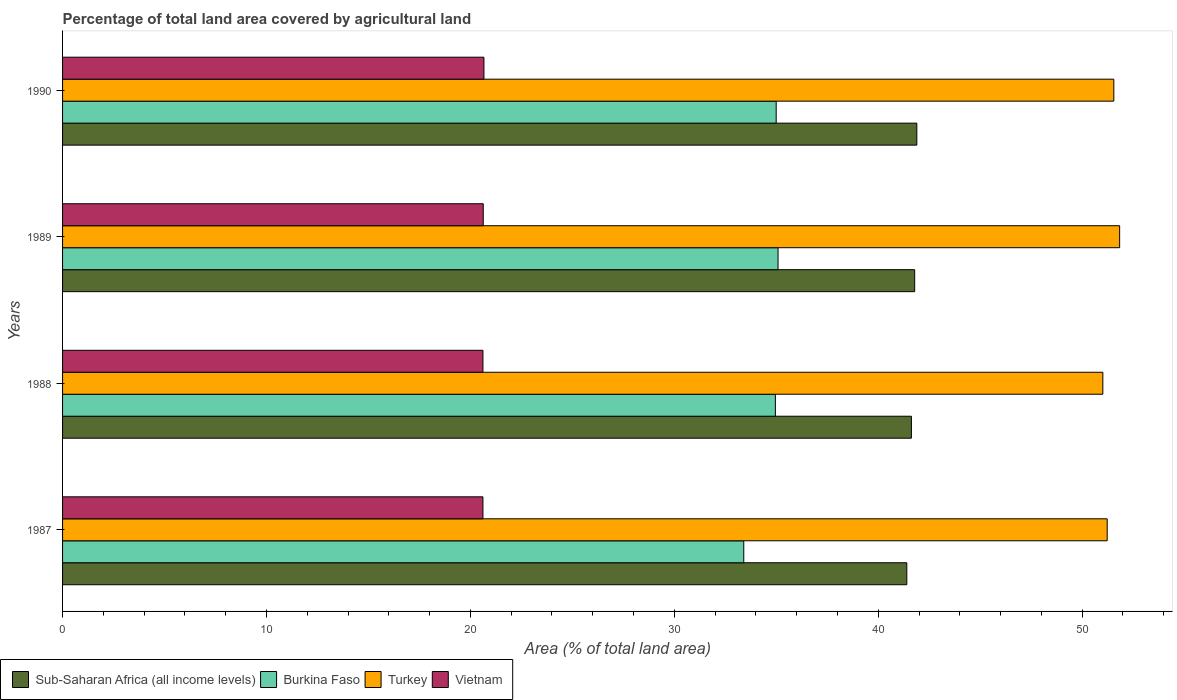Are the number of bars on each tick of the Y-axis equal?
Offer a terse response. Yes. How many bars are there on the 2nd tick from the top?
Offer a terse response. 4. What is the label of the 4th group of bars from the top?
Your response must be concise. 1987. In how many cases, is the number of bars for a given year not equal to the number of legend labels?
Offer a terse response. 0. What is the percentage of agricultural land in Sub-Saharan Africa (all income levels) in 1987?
Provide a short and direct response. 41.4. Across all years, what is the maximum percentage of agricultural land in Sub-Saharan Africa (all income levels)?
Provide a short and direct response. 41.89. Across all years, what is the minimum percentage of agricultural land in Vietnam?
Offer a terse response. 20.62. In which year was the percentage of agricultural land in Vietnam minimum?
Provide a short and direct response. 1987. What is the total percentage of agricultural land in Turkey in the graph?
Offer a terse response. 205.64. What is the difference between the percentage of agricultural land in Sub-Saharan Africa (all income levels) in 1987 and that in 1990?
Ensure brevity in your answer.  -0.49. What is the difference between the percentage of agricultural land in Sub-Saharan Africa (all income levels) in 1987 and the percentage of agricultural land in Burkina Faso in 1988?
Your answer should be very brief. 6.45. What is the average percentage of agricultural land in Turkey per year?
Your answer should be very brief. 51.41. In the year 1987, what is the difference between the percentage of agricultural land in Vietnam and percentage of agricultural land in Turkey?
Provide a short and direct response. -30.61. In how many years, is the percentage of agricultural land in Sub-Saharan Africa (all income levels) greater than 48 %?
Offer a terse response. 0. What is the ratio of the percentage of agricultural land in Burkina Faso in 1987 to that in 1990?
Give a very brief answer. 0.95. Is the percentage of agricultural land in Sub-Saharan Africa (all income levels) in 1987 less than that in 1988?
Provide a succinct answer. Yes. What is the difference between the highest and the second highest percentage of agricultural land in Sub-Saharan Africa (all income levels)?
Offer a terse response. 0.11. What is the difference between the highest and the lowest percentage of agricultural land in Vietnam?
Keep it short and to the point. 0.05. Is it the case that in every year, the sum of the percentage of agricultural land in Vietnam and percentage of agricultural land in Burkina Faso is greater than the sum of percentage of agricultural land in Turkey and percentage of agricultural land in Sub-Saharan Africa (all income levels)?
Ensure brevity in your answer.  No. What does the 2nd bar from the top in 1989 represents?
Give a very brief answer. Turkey. What does the 4th bar from the bottom in 1987 represents?
Offer a very short reply. Vietnam. Is it the case that in every year, the sum of the percentage of agricultural land in Burkina Faso and percentage of agricultural land in Turkey is greater than the percentage of agricultural land in Sub-Saharan Africa (all income levels)?
Offer a terse response. Yes. How many bars are there?
Offer a very short reply. 16. What is the difference between two consecutive major ticks on the X-axis?
Your answer should be compact. 10. Does the graph contain any zero values?
Provide a short and direct response. No. Does the graph contain grids?
Your answer should be compact. No. Where does the legend appear in the graph?
Offer a very short reply. Bottom left. How are the legend labels stacked?
Offer a very short reply. Horizontal. What is the title of the graph?
Your response must be concise. Percentage of total land area covered by agricultural land. What is the label or title of the X-axis?
Offer a terse response. Area (% of total land area). What is the label or title of the Y-axis?
Keep it short and to the point. Years. What is the Area (% of total land area) in Sub-Saharan Africa (all income levels) in 1987?
Keep it short and to the point. 41.4. What is the Area (% of total land area) in Burkina Faso in 1987?
Offer a terse response. 33.41. What is the Area (% of total land area) in Turkey in 1987?
Ensure brevity in your answer.  51.23. What is the Area (% of total land area) of Vietnam in 1987?
Provide a short and direct response. 20.62. What is the Area (% of total land area) of Sub-Saharan Africa (all income levels) in 1988?
Give a very brief answer. 41.63. What is the Area (% of total land area) of Burkina Faso in 1988?
Provide a short and direct response. 34.96. What is the Area (% of total land area) in Turkey in 1988?
Your response must be concise. 51.02. What is the Area (% of total land area) of Vietnam in 1988?
Give a very brief answer. 20.62. What is the Area (% of total land area) in Sub-Saharan Africa (all income levels) in 1989?
Keep it short and to the point. 41.79. What is the Area (% of total land area) in Burkina Faso in 1989?
Make the answer very short. 35.09. What is the Area (% of total land area) in Turkey in 1989?
Your answer should be very brief. 51.84. What is the Area (% of total land area) in Vietnam in 1989?
Provide a short and direct response. 20.63. What is the Area (% of total land area) of Sub-Saharan Africa (all income levels) in 1990?
Your answer should be compact. 41.89. What is the Area (% of total land area) of Burkina Faso in 1990?
Give a very brief answer. 35. What is the Area (% of total land area) of Turkey in 1990?
Your answer should be compact. 51.55. What is the Area (% of total land area) of Vietnam in 1990?
Offer a terse response. 20.66. Across all years, what is the maximum Area (% of total land area) in Sub-Saharan Africa (all income levels)?
Offer a very short reply. 41.89. Across all years, what is the maximum Area (% of total land area) in Burkina Faso?
Offer a terse response. 35.09. Across all years, what is the maximum Area (% of total land area) in Turkey?
Give a very brief answer. 51.84. Across all years, what is the maximum Area (% of total land area) of Vietnam?
Offer a very short reply. 20.66. Across all years, what is the minimum Area (% of total land area) of Sub-Saharan Africa (all income levels)?
Keep it short and to the point. 41.4. Across all years, what is the minimum Area (% of total land area) in Burkina Faso?
Your response must be concise. 33.41. Across all years, what is the minimum Area (% of total land area) of Turkey?
Your response must be concise. 51.02. Across all years, what is the minimum Area (% of total land area) of Vietnam?
Make the answer very short. 20.62. What is the total Area (% of total land area) of Sub-Saharan Africa (all income levels) in the graph?
Give a very brief answer. 166.71. What is the total Area (% of total land area) of Burkina Faso in the graph?
Keep it short and to the point. 138.45. What is the total Area (% of total land area) of Turkey in the graph?
Offer a terse response. 205.64. What is the total Area (% of total land area) of Vietnam in the graph?
Ensure brevity in your answer.  82.52. What is the difference between the Area (% of total land area) in Sub-Saharan Africa (all income levels) in 1987 and that in 1988?
Offer a very short reply. -0.22. What is the difference between the Area (% of total land area) of Burkina Faso in 1987 and that in 1988?
Your response must be concise. -1.55. What is the difference between the Area (% of total land area) of Turkey in 1987 and that in 1988?
Keep it short and to the point. 0.21. What is the difference between the Area (% of total land area) in Vietnam in 1987 and that in 1988?
Ensure brevity in your answer.  0. What is the difference between the Area (% of total land area) in Sub-Saharan Africa (all income levels) in 1987 and that in 1989?
Ensure brevity in your answer.  -0.38. What is the difference between the Area (% of total land area) of Burkina Faso in 1987 and that in 1989?
Keep it short and to the point. -1.68. What is the difference between the Area (% of total land area) of Turkey in 1987 and that in 1989?
Your answer should be very brief. -0.61. What is the difference between the Area (% of total land area) of Vietnam in 1987 and that in 1989?
Your answer should be very brief. -0.02. What is the difference between the Area (% of total land area) in Sub-Saharan Africa (all income levels) in 1987 and that in 1990?
Provide a short and direct response. -0.49. What is the difference between the Area (% of total land area) of Burkina Faso in 1987 and that in 1990?
Your response must be concise. -1.59. What is the difference between the Area (% of total land area) of Turkey in 1987 and that in 1990?
Offer a very short reply. -0.32. What is the difference between the Area (% of total land area) of Vietnam in 1987 and that in 1990?
Provide a short and direct response. -0.05. What is the difference between the Area (% of total land area) of Sub-Saharan Africa (all income levels) in 1988 and that in 1989?
Provide a succinct answer. -0.16. What is the difference between the Area (% of total land area) in Burkina Faso in 1988 and that in 1989?
Keep it short and to the point. -0.13. What is the difference between the Area (% of total land area) of Turkey in 1988 and that in 1989?
Ensure brevity in your answer.  -0.82. What is the difference between the Area (% of total land area) of Vietnam in 1988 and that in 1989?
Offer a very short reply. -0.02. What is the difference between the Area (% of total land area) of Sub-Saharan Africa (all income levels) in 1988 and that in 1990?
Offer a very short reply. -0.27. What is the difference between the Area (% of total land area) of Burkina Faso in 1988 and that in 1990?
Provide a short and direct response. -0.04. What is the difference between the Area (% of total land area) of Turkey in 1988 and that in 1990?
Your answer should be compact. -0.54. What is the difference between the Area (% of total land area) in Vietnam in 1988 and that in 1990?
Your answer should be compact. -0.05. What is the difference between the Area (% of total land area) of Sub-Saharan Africa (all income levels) in 1989 and that in 1990?
Provide a short and direct response. -0.11. What is the difference between the Area (% of total land area) in Burkina Faso in 1989 and that in 1990?
Give a very brief answer. 0.09. What is the difference between the Area (% of total land area) of Turkey in 1989 and that in 1990?
Provide a short and direct response. 0.29. What is the difference between the Area (% of total land area) of Vietnam in 1989 and that in 1990?
Ensure brevity in your answer.  -0.03. What is the difference between the Area (% of total land area) of Sub-Saharan Africa (all income levels) in 1987 and the Area (% of total land area) of Burkina Faso in 1988?
Your answer should be compact. 6.45. What is the difference between the Area (% of total land area) of Sub-Saharan Africa (all income levels) in 1987 and the Area (% of total land area) of Turkey in 1988?
Offer a terse response. -9.61. What is the difference between the Area (% of total land area) of Sub-Saharan Africa (all income levels) in 1987 and the Area (% of total land area) of Vietnam in 1988?
Offer a very short reply. 20.79. What is the difference between the Area (% of total land area) in Burkina Faso in 1987 and the Area (% of total land area) in Turkey in 1988?
Your answer should be compact. -17.61. What is the difference between the Area (% of total land area) of Burkina Faso in 1987 and the Area (% of total land area) of Vietnam in 1988?
Make the answer very short. 12.79. What is the difference between the Area (% of total land area) of Turkey in 1987 and the Area (% of total land area) of Vietnam in 1988?
Your answer should be compact. 30.61. What is the difference between the Area (% of total land area) of Sub-Saharan Africa (all income levels) in 1987 and the Area (% of total land area) of Burkina Faso in 1989?
Offer a terse response. 6.31. What is the difference between the Area (% of total land area) of Sub-Saharan Africa (all income levels) in 1987 and the Area (% of total land area) of Turkey in 1989?
Offer a very short reply. -10.44. What is the difference between the Area (% of total land area) of Sub-Saharan Africa (all income levels) in 1987 and the Area (% of total land area) of Vietnam in 1989?
Your answer should be compact. 20.77. What is the difference between the Area (% of total land area) in Burkina Faso in 1987 and the Area (% of total land area) in Turkey in 1989?
Your answer should be compact. -18.43. What is the difference between the Area (% of total land area) of Burkina Faso in 1987 and the Area (% of total land area) of Vietnam in 1989?
Provide a short and direct response. 12.78. What is the difference between the Area (% of total land area) of Turkey in 1987 and the Area (% of total land area) of Vietnam in 1989?
Your answer should be compact. 30.6. What is the difference between the Area (% of total land area) in Sub-Saharan Africa (all income levels) in 1987 and the Area (% of total land area) in Burkina Faso in 1990?
Offer a terse response. 6.41. What is the difference between the Area (% of total land area) of Sub-Saharan Africa (all income levels) in 1987 and the Area (% of total land area) of Turkey in 1990?
Ensure brevity in your answer.  -10.15. What is the difference between the Area (% of total land area) in Sub-Saharan Africa (all income levels) in 1987 and the Area (% of total land area) in Vietnam in 1990?
Your answer should be compact. 20.74. What is the difference between the Area (% of total land area) in Burkina Faso in 1987 and the Area (% of total land area) in Turkey in 1990?
Your response must be concise. -18.15. What is the difference between the Area (% of total land area) in Burkina Faso in 1987 and the Area (% of total land area) in Vietnam in 1990?
Your response must be concise. 12.74. What is the difference between the Area (% of total land area) in Turkey in 1987 and the Area (% of total land area) in Vietnam in 1990?
Offer a terse response. 30.56. What is the difference between the Area (% of total land area) of Sub-Saharan Africa (all income levels) in 1988 and the Area (% of total land area) of Burkina Faso in 1989?
Your response must be concise. 6.54. What is the difference between the Area (% of total land area) of Sub-Saharan Africa (all income levels) in 1988 and the Area (% of total land area) of Turkey in 1989?
Offer a terse response. -10.21. What is the difference between the Area (% of total land area) of Sub-Saharan Africa (all income levels) in 1988 and the Area (% of total land area) of Vietnam in 1989?
Offer a very short reply. 21. What is the difference between the Area (% of total land area) in Burkina Faso in 1988 and the Area (% of total land area) in Turkey in 1989?
Offer a very short reply. -16.88. What is the difference between the Area (% of total land area) in Burkina Faso in 1988 and the Area (% of total land area) in Vietnam in 1989?
Provide a short and direct response. 14.33. What is the difference between the Area (% of total land area) of Turkey in 1988 and the Area (% of total land area) of Vietnam in 1989?
Ensure brevity in your answer.  30.39. What is the difference between the Area (% of total land area) in Sub-Saharan Africa (all income levels) in 1988 and the Area (% of total land area) in Burkina Faso in 1990?
Your answer should be very brief. 6.63. What is the difference between the Area (% of total land area) in Sub-Saharan Africa (all income levels) in 1988 and the Area (% of total land area) in Turkey in 1990?
Ensure brevity in your answer.  -9.93. What is the difference between the Area (% of total land area) of Sub-Saharan Africa (all income levels) in 1988 and the Area (% of total land area) of Vietnam in 1990?
Offer a very short reply. 20.96. What is the difference between the Area (% of total land area) of Burkina Faso in 1988 and the Area (% of total land area) of Turkey in 1990?
Give a very brief answer. -16.6. What is the difference between the Area (% of total land area) in Burkina Faso in 1988 and the Area (% of total land area) in Vietnam in 1990?
Make the answer very short. 14.29. What is the difference between the Area (% of total land area) in Turkey in 1988 and the Area (% of total land area) in Vietnam in 1990?
Provide a short and direct response. 30.35. What is the difference between the Area (% of total land area) in Sub-Saharan Africa (all income levels) in 1989 and the Area (% of total land area) in Burkina Faso in 1990?
Provide a succinct answer. 6.79. What is the difference between the Area (% of total land area) in Sub-Saharan Africa (all income levels) in 1989 and the Area (% of total land area) in Turkey in 1990?
Provide a short and direct response. -9.77. What is the difference between the Area (% of total land area) of Sub-Saharan Africa (all income levels) in 1989 and the Area (% of total land area) of Vietnam in 1990?
Make the answer very short. 21.12. What is the difference between the Area (% of total land area) of Burkina Faso in 1989 and the Area (% of total land area) of Turkey in 1990?
Keep it short and to the point. -16.47. What is the difference between the Area (% of total land area) in Burkina Faso in 1989 and the Area (% of total land area) in Vietnam in 1990?
Give a very brief answer. 14.42. What is the difference between the Area (% of total land area) in Turkey in 1989 and the Area (% of total land area) in Vietnam in 1990?
Provide a succinct answer. 31.18. What is the average Area (% of total land area) in Sub-Saharan Africa (all income levels) per year?
Your answer should be very brief. 41.68. What is the average Area (% of total land area) of Burkina Faso per year?
Make the answer very short. 34.61. What is the average Area (% of total land area) in Turkey per year?
Provide a short and direct response. 51.41. What is the average Area (% of total land area) in Vietnam per year?
Offer a very short reply. 20.63. In the year 1987, what is the difference between the Area (% of total land area) of Sub-Saharan Africa (all income levels) and Area (% of total land area) of Burkina Faso?
Offer a terse response. 8. In the year 1987, what is the difference between the Area (% of total land area) of Sub-Saharan Africa (all income levels) and Area (% of total land area) of Turkey?
Your answer should be very brief. -9.83. In the year 1987, what is the difference between the Area (% of total land area) of Sub-Saharan Africa (all income levels) and Area (% of total land area) of Vietnam?
Give a very brief answer. 20.79. In the year 1987, what is the difference between the Area (% of total land area) in Burkina Faso and Area (% of total land area) in Turkey?
Your response must be concise. -17.82. In the year 1987, what is the difference between the Area (% of total land area) in Burkina Faso and Area (% of total land area) in Vietnam?
Make the answer very short. 12.79. In the year 1987, what is the difference between the Area (% of total land area) of Turkey and Area (% of total land area) of Vietnam?
Ensure brevity in your answer.  30.61. In the year 1988, what is the difference between the Area (% of total land area) in Sub-Saharan Africa (all income levels) and Area (% of total land area) in Burkina Faso?
Offer a very short reply. 6.67. In the year 1988, what is the difference between the Area (% of total land area) of Sub-Saharan Africa (all income levels) and Area (% of total land area) of Turkey?
Your answer should be very brief. -9.39. In the year 1988, what is the difference between the Area (% of total land area) in Sub-Saharan Africa (all income levels) and Area (% of total land area) in Vietnam?
Your answer should be very brief. 21.01. In the year 1988, what is the difference between the Area (% of total land area) of Burkina Faso and Area (% of total land area) of Turkey?
Provide a succinct answer. -16.06. In the year 1988, what is the difference between the Area (% of total land area) in Burkina Faso and Area (% of total land area) in Vietnam?
Provide a short and direct response. 14.34. In the year 1988, what is the difference between the Area (% of total land area) of Turkey and Area (% of total land area) of Vietnam?
Make the answer very short. 30.4. In the year 1989, what is the difference between the Area (% of total land area) of Sub-Saharan Africa (all income levels) and Area (% of total land area) of Burkina Faso?
Give a very brief answer. 6.7. In the year 1989, what is the difference between the Area (% of total land area) in Sub-Saharan Africa (all income levels) and Area (% of total land area) in Turkey?
Offer a terse response. -10.05. In the year 1989, what is the difference between the Area (% of total land area) in Sub-Saharan Africa (all income levels) and Area (% of total land area) in Vietnam?
Give a very brief answer. 21.16. In the year 1989, what is the difference between the Area (% of total land area) in Burkina Faso and Area (% of total land area) in Turkey?
Your answer should be very brief. -16.75. In the year 1989, what is the difference between the Area (% of total land area) of Burkina Faso and Area (% of total land area) of Vietnam?
Offer a terse response. 14.46. In the year 1989, what is the difference between the Area (% of total land area) of Turkey and Area (% of total land area) of Vietnam?
Keep it short and to the point. 31.21. In the year 1990, what is the difference between the Area (% of total land area) of Sub-Saharan Africa (all income levels) and Area (% of total land area) of Burkina Faso?
Give a very brief answer. 6.9. In the year 1990, what is the difference between the Area (% of total land area) in Sub-Saharan Africa (all income levels) and Area (% of total land area) in Turkey?
Give a very brief answer. -9.66. In the year 1990, what is the difference between the Area (% of total land area) of Sub-Saharan Africa (all income levels) and Area (% of total land area) of Vietnam?
Provide a short and direct response. 21.23. In the year 1990, what is the difference between the Area (% of total land area) in Burkina Faso and Area (% of total land area) in Turkey?
Your response must be concise. -16.56. In the year 1990, what is the difference between the Area (% of total land area) of Burkina Faso and Area (% of total land area) of Vietnam?
Ensure brevity in your answer.  14.33. In the year 1990, what is the difference between the Area (% of total land area) in Turkey and Area (% of total land area) in Vietnam?
Your answer should be compact. 30.89. What is the ratio of the Area (% of total land area) of Burkina Faso in 1987 to that in 1988?
Make the answer very short. 0.96. What is the ratio of the Area (% of total land area) in Turkey in 1987 to that in 1988?
Offer a very short reply. 1. What is the ratio of the Area (% of total land area) of Vietnam in 1987 to that in 1988?
Offer a terse response. 1. What is the ratio of the Area (% of total land area) of Sub-Saharan Africa (all income levels) in 1987 to that in 1989?
Offer a very short reply. 0.99. What is the ratio of the Area (% of total land area) in Burkina Faso in 1987 to that in 1989?
Offer a very short reply. 0.95. What is the ratio of the Area (% of total land area) of Sub-Saharan Africa (all income levels) in 1987 to that in 1990?
Offer a very short reply. 0.99. What is the ratio of the Area (% of total land area) of Burkina Faso in 1987 to that in 1990?
Give a very brief answer. 0.95. What is the ratio of the Area (% of total land area) of Vietnam in 1987 to that in 1990?
Ensure brevity in your answer.  1. What is the ratio of the Area (% of total land area) in Burkina Faso in 1988 to that in 1989?
Make the answer very short. 1. What is the ratio of the Area (% of total land area) in Turkey in 1988 to that in 1989?
Provide a succinct answer. 0.98. What is the ratio of the Area (% of total land area) of Vietnam in 1988 to that in 1989?
Your answer should be very brief. 1. What is the ratio of the Area (% of total land area) in Sub-Saharan Africa (all income levels) in 1988 to that in 1990?
Your answer should be very brief. 0.99. What is the ratio of the Area (% of total land area) in Burkina Faso in 1988 to that in 1990?
Ensure brevity in your answer.  1. What is the ratio of the Area (% of total land area) of Turkey in 1988 to that in 1990?
Offer a terse response. 0.99. What is the ratio of the Area (% of total land area) of Turkey in 1989 to that in 1990?
Your answer should be compact. 1.01. What is the difference between the highest and the second highest Area (% of total land area) of Sub-Saharan Africa (all income levels)?
Your answer should be very brief. 0.11. What is the difference between the highest and the second highest Area (% of total land area) in Burkina Faso?
Offer a terse response. 0.09. What is the difference between the highest and the second highest Area (% of total land area) in Turkey?
Ensure brevity in your answer.  0.29. What is the difference between the highest and the second highest Area (% of total land area) of Vietnam?
Offer a very short reply. 0.03. What is the difference between the highest and the lowest Area (% of total land area) in Sub-Saharan Africa (all income levels)?
Your answer should be very brief. 0.49. What is the difference between the highest and the lowest Area (% of total land area) in Burkina Faso?
Give a very brief answer. 1.68. What is the difference between the highest and the lowest Area (% of total land area) in Turkey?
Give a very brief answer. 0.82. What is the difference between the highest and the lowest Area (% of total land area) of Vietnam?
Make the answer very short. 0.05. 